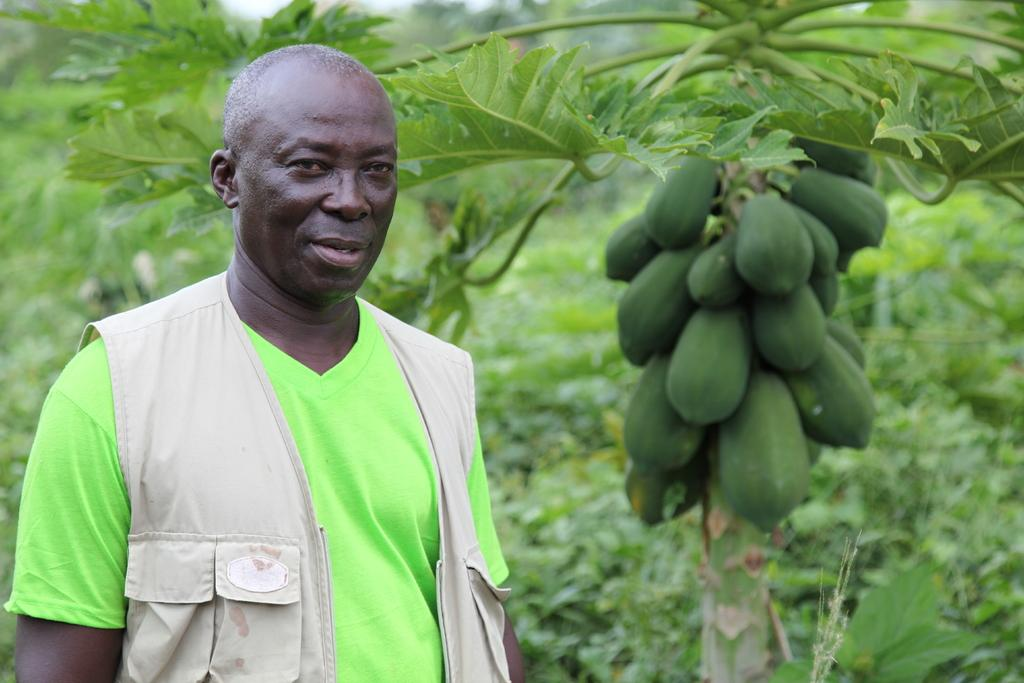Who is present in the image? There is a man in the image. Where is the man located in the image? The man is on the left side of the image. What is the man wearing? The man is wearing a green color t-shirt and a jacket. What can be seen in the background of the image? There are trees and fruits in the background of the image. What type of regret can be seen on the man's face in the image? There is no indication of regret on the man's face in the image, as the provided facts do not mention any emotions or expressions. 